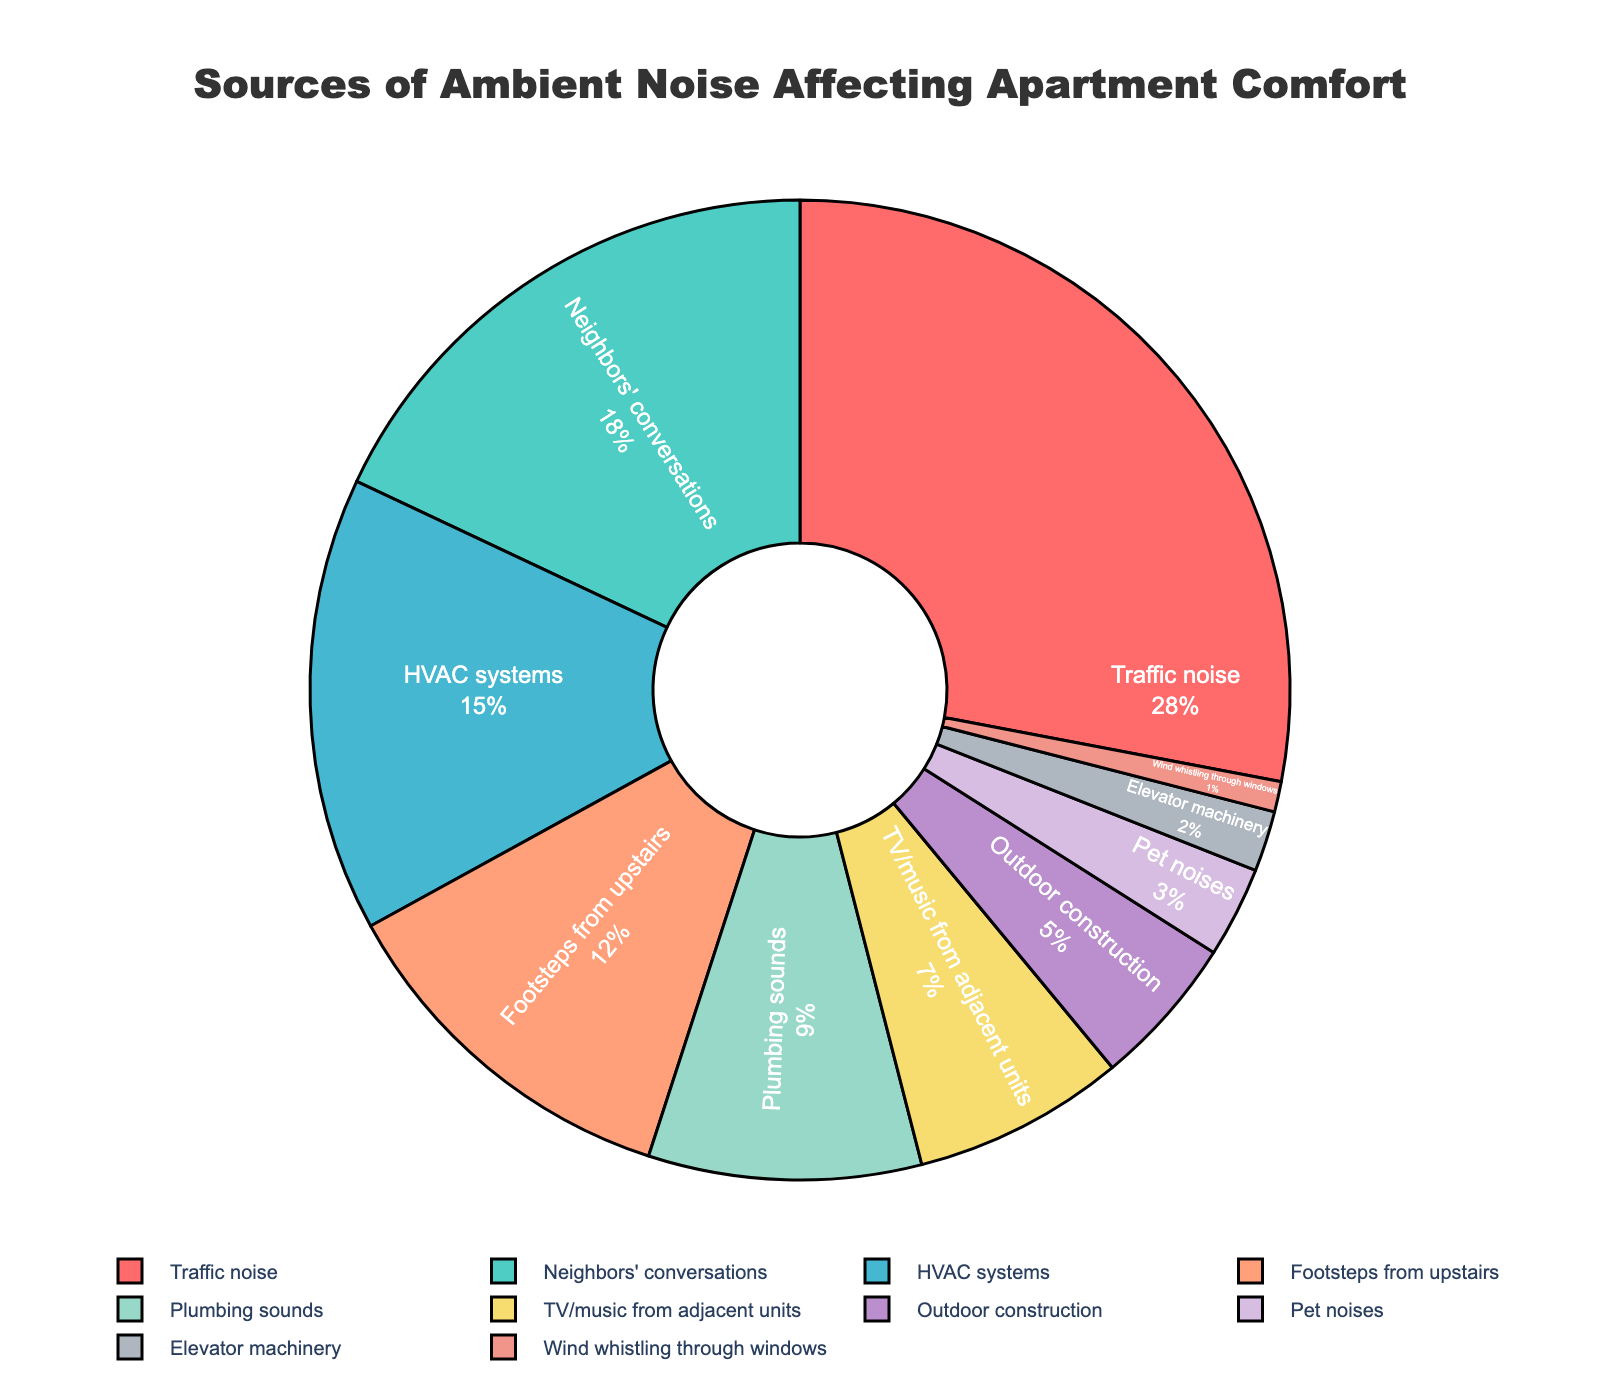Which noise source has the highest percentage of impact on apartment comfort? The slice corresponding to "Traffic noise" is the largest in the pie chart and shows the percentage value of 28%, which is the highest among all other sources.
Answer: Traffic noise What is the combined percentage of noise caused by neighbors' conversations and footsteps from upstairs? The two segments "Neighbors' conversations" and "Footsteps from upstairs" represent 18% and 12% respectively. Adding these together gives 18 + 12 = 30%.
Answer: 30% Compare the impact of HVAC systems to TV/music from adjacent units. Which one is more significant and by how much? The pie chart shows HVAC systems at 15% and TV/music from adjacent units at 7%. The difference can be calculated as 15 - 7 = 8%. HVAC systems are more significant.
Answer: HVAC systems, by 8% Which noise sources contribute less than 10% each to the total ambient noise? By inspecting the pie chart, "Plumbing sounds" (9%), "TV/music from adjacent units" (7%), "Outdoor construction" (5%), "Pet noises" (3%), "Elevator machinery" (2%), and "Wind whistling through windows" (1%) all contribute less than 10%.
Answer: Plumbing sounds, TV/music from adjacent units, Outdoor construction, Pet noises, Elevator machinery, Wind whistling through windows What is the difference in impact between the most significant noise source and the least significant one? "Traffic noise" is the most significant source at 28% and "Wind whistling through windows" is the least at 1%. The difference is calculated as 28 - 1 = 27%.
Answer: 27% If we group neighbors' conversations and TV/music from adjacent units as 'noise from neighbors', what percentage does this group contribute to the whole? Neighbors' conversations contribute 18% and TV/music from adjacent units contribute 7%. Adding these together gives 18 + 7 = 25%.
Answer: 25% Which sources have a larger impact: HVAC systems and plumbing sounds together, or neighbors' conversations alone? HVAC systems and plumbing sounds together have a combined impact of 15% + 9% = 24%. Neighbors' conversations alone contribute 18%. Hence, HVAC systems and plumbing sounds together have a larger impact.
Answer: HVAC systems and plumbing sounds What percentage of noise is caused by outdoor sources (Traffic noise, Outdoor construction, and Wind whistling through windows)? Summing the percentages of "Traffic noise" (28%), "Outdoor construction" (5%), and "Wind whistling through windows" (1%) gives 28 + 5 + 1 = 34%.
Answer: 34% Rank the noise sources from least to most impactful. By inspecting and sorting the percentage values in the pie chart: Wind whistling through windows (1%), Elevator machinery (2%), Pet noises (3%), Outdoor construction (5%), TV/music from adjacent units (7%), Plumbing sounds (9%), Footsteps from upstairs (12%), HVAC systems (15%), Neighbors' conversations (18%), Traffic noise (28%).
Answer: Wind whistling through windows, Elevator machinery, Pet noises, Outdoor construction, TV/music from adjacent units, Plumbing sounds, Footsteps from upstairs, HVAC systems, Neighbors' conversations, Traffic noise 